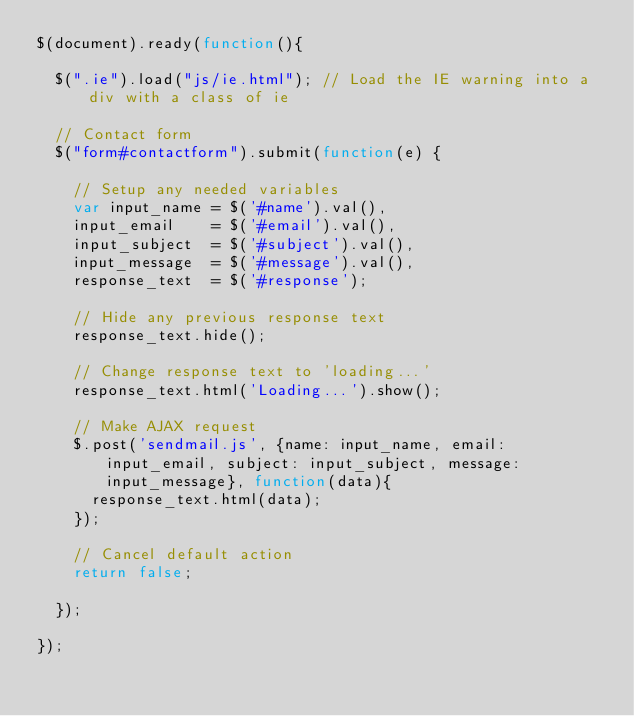Convert code to text. <code><loc_0><loc_0><loc_500><loc_500><_JavaScript_>$(document).ready(function(){

	$(".ie").load("js/ie.html"); // Load the IE warning into a div with a class of ie
	
	// Contact form
	$("form#contactform").submit(function(e) {
		
		// Setup any needed variables
		var input_name = $('#name').val(),
		input_email    = $('#email').val(),
		input_subject  = $('#subject').val(),
		input_message  = $('#message').val(),
		response_text  = $('#response');
		
		// Hide any previous response text
		response_text.hide();

		// Change response text to 'loading...'
		response_text.html('Loading...').show();

		// Make AJAX request
		$.post('sendmail.js', {name: input_name, email: input_email, subject: input_subject, message: input_message}, function(data){
			response_text.html(data);
		});

		// Cancel default action
		return false;
		
	});
	
});</code> 